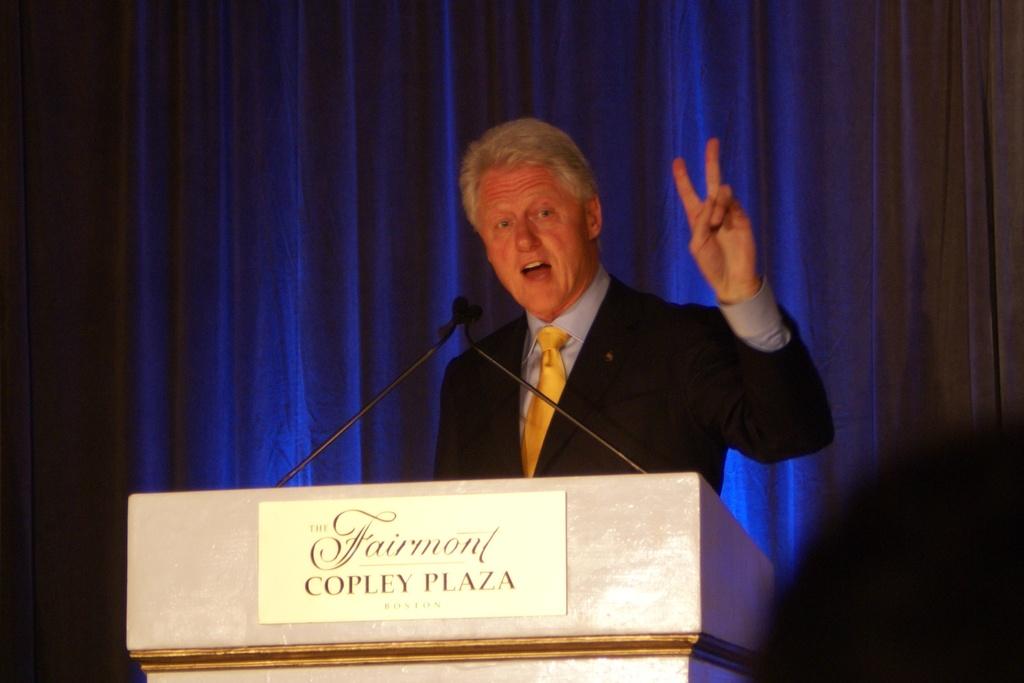Where was this speech by bill clinton held?
Provide a succinct answer. Fairmont copley plaza. What city is the fairmont in?
Offer a terse response. Boston. 